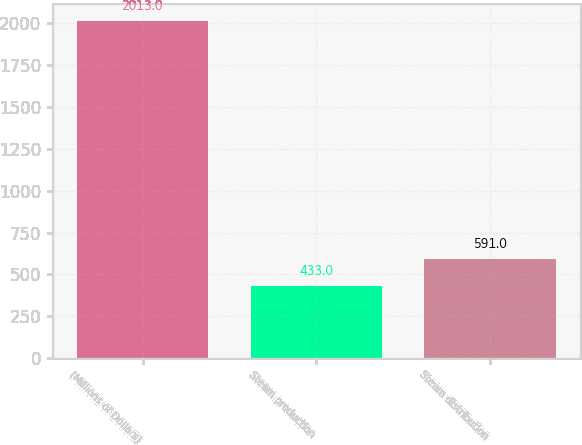Convert chart to OTSL. <chart><loc_0><loc_0><loc_500><loc_500><bar_chart><fcel>(Millions of Dollars)<fcel>Steam production<fcel>Steam distribution<nl><fcel>2013<fcel>433<fcel>591<nl></chart> 